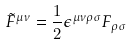<formula> <loc_0><loc_0><loc_500><loc_500>\tilde { F } ^ { \mu \nu } = \frac { 1 } { 2 } \epsilon ^ { \mu \nu \rho \sigma } F _ { \rho \sigma }</formula> 